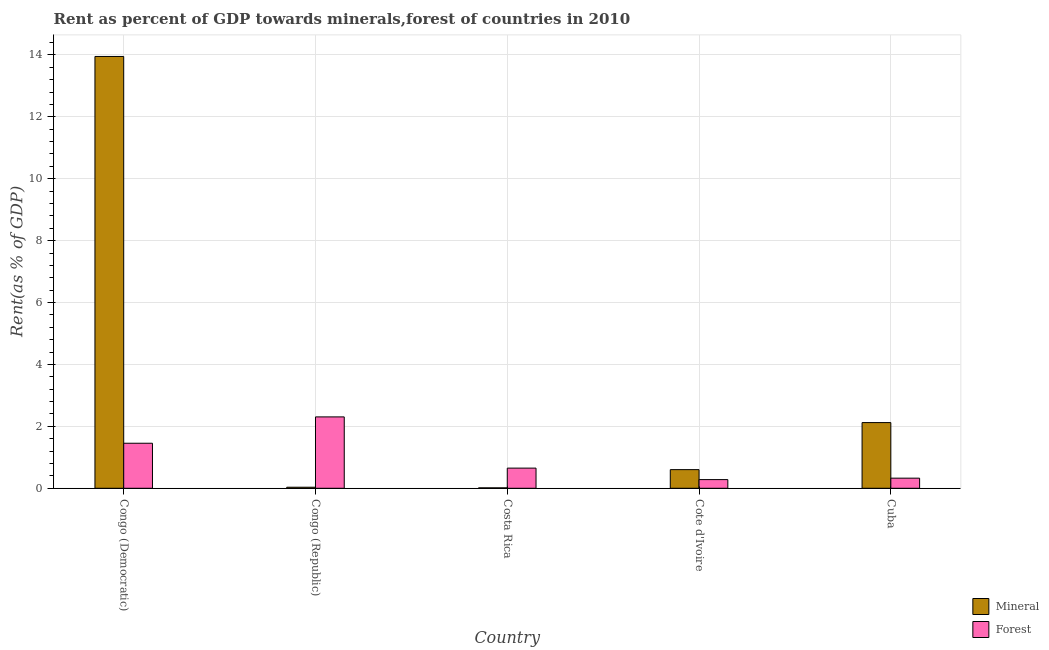How many different coloured bars are there?
Give a very brief answer. 2. How many groups of bars are there?
Ensure brevity in your answer.  5. Are the number of bars per tick equal to the number of legend labels?
Ensure brevity in your answer.  Yes. How many bars are there on the 2nd tick from the left?
Ensure brevity in your answer.  2. In how many cases, is the number of bars for a given country not equal to the number of legend labels?
Your answer should be compact. 0. What is the mineral rent in Cote d'Ivoire?
Offer a very short reply. 0.6. Across all countries, what is the maximum forest rent?
Make the answer very short. 2.31. Across all countries, what is the minimum forest rent?
Keep it short and to the point. 0.28. In which country was the forest rent maximum?
Offer a terse response. Congo (Republic). In which country was the forest rent minimum?
Keep it short and to the point. Cote d'Ivoire. What is the total forest rent in the graph?
Make the answer very short. 5.02. What is the difference between the mineral rent in Cote d'Ivoire and that in Cuba?
Make the answer very short. -1.52. What is the difference between the forest rent in Cuba and the mineral rent in Costa Rica?
Your response must be concise. 0.31. What is the average mineral rent per country?
Make the answer very short. 3.34. What is the difference between the mineral rent and forest rent in Congo (Republic)?
Your answer should be compact. -2.27. In how many countries, is the forest rent greater than 4 %?
Offer a very short reply. 0. What is the ratio of the mineral rent in Costa Rica to that in Cote d'Ivoire?
Keep it short and to the point. 0.02. What is the difference between the highest and the second highest mineral rent?
Keep it short and to the point. 11.83. What is the difference between the highest and the lowest mineral rent?
Your answer should be very brief. 13.93. Is the sum of the mineral rent in Congo (Republic) and Cuba greater than the maximum forest rent across all countries?
Provide a succinct answer. No. What does the 2nd bar from the left in Costa Rica represents?
Give a very brief answer. Forest. What does the 1st bar from the right in Cote d'Ivoire represents?
Provide a short and direct response. Forest. How many bars are there?
Give a very brief answer. 10. Are all the bars in the graph horizontal?
Provide a succinct answer. No. How many countries are there in the graph?
Offer a very short reply. 5. Does the graph contain grids?
Provide a short and direct response. Yes. Where does the legend appear in the graph?
Keep it short and to the point. Bottom right. How are the legend labels stacked?
Your response must be concise. Vertical. What is the title of the graph?
Make the answer very short. Rent as percent of GDP towards minerals,forest of countries in 2010. What is the label or title of the Y-axis?
Your answer should be very brief. Rent(as % of GDP). What is the Rent(as % of GDP) in Mineral in Congo (Democratic)?
Your answer should be compact. 13.95. What is the Rent(as % of GDP) in Forest in Congo (Democratic)?
Give a very brief answer. 1.45. What is the Rent(as % of GDP) in Mineral in Congo (Republic)?
Your answer should be compact. 0.03. What is the Rent(as % of GDP) of Forest in Congo (Republic)?
Provide a short and direct response. 2.31. What is the Rent(as % of GDP) of Mineral in Costa Rica?
Your response must be concise. 0.01. What is the Rent(as % of GDP) of Forest in Costa Rica?
Ensure brevity in your answer.  0.65. What is the Rent(as % of GDP) in Mineral in Cote d'Ivoire?
Provide a short and direct response. 0.6. What is the Rent(as % of GDP) of Forest in Cote d'Ivoire?
Make the answer very short. 0.28. What is the Rent(as % of GDP) in Mineral in Cuba?
Keep it short and to the point. 2.12. What is the Rent(as % of GDP) in Forest in Cuba?
Your answer should be very brief. 0.33. Across all countries, what is the maximum Rent(as % of GDP) of Mineral?
Make the answer very short. 13.95. Across all countries, what is the maximum Rent(as % of GDP) of Forest?
Keep it short and to the point. 2.31. Across all countries, what is the minimum Rent(as % of GDP) of Mineral?
Your response must be concise. 0.01. Across all countries, what is the minimum Rent(as % of GDP) of Forest?
Make the answer very short. 0.28. What is the total Rent(as % of GDP) in Mineral in the graph?
Your answer should be compact. 16.72. What is the total Rent(as % of GDP) of Forest in the graph?
Make the answer very short. 5.02. What is the difference between the Rent(as % of GDP) of Mineral in Congo (Democratic) and that in Congo (Republic)?
Keep it short and to the point. 13.91. What is the difference between the Rent(as % of GDP) in Forest in Congo (Democratic) and that in Congo (Republic)?
Offer a terse response. -0.85. What is the difference between the Rent(as % of GDP) in Mineral in Congo (Democratic) and that in Costa Rica?
Offer a terse response. 13.93. What is the difference between the Rent(as % of GDP) of Forest in Congo (Democratic) and that in Costa Rica?
Provide a short and direct response. 0.8. What is the difference between the Rent(as % of GDP) of Mineral in Congo (Democratic) and that in Cote d'Ivoire?
Provide a succinct answer. 13.35. What is the difference between the Rent(as % of GDP) in Forest in Congo (Democratic) and that in Cote d'Ivoire?
Your response must be concise. 1.17. What is the difference between the Rent(as % of GDP) of Mineral in Congo (Democratic) and that in Cuba?
Your answer should be compact. 11.83. What is the difference between the Rent(as % of GDP) in Forest in Congo (Democratic) and that in Cuba?
Give a very brief answer. 1.13. What is the difference between the Rent(as % of GDP) of Mineral in Congo (Republic) and that in Costa Rica?
Ensure brevity in your answer.  0.02. What is the difference between the Rent(as % of GDP) of Forest in Congo (Republic) and that in Costa Rica?
Make the answer very short. 1.65. What is the difference between the Rent(as % of GDP) of Mineral in Congo (Republic) and that in Cote d'Ivoire?
Your response must be concise. -0.57. What is the difference between the Rent(as % of GDP) in Forest in Congo (Republic) and that in Cote d'Ivoire?
Give a very brief answer. 2.03. What is the difference between the Rent(as % of GDP) in Mineral in Congo (Republic) and that in Cuba?
Provide a short and direct response. -2.09. What is the difference between the Rent(as % of GDP) of Forest in Congo (Republic) and that in Cuba?
Make the answer very short. 1.98. What is the difference between the Rent(as % of GDP) of Mineral in Costa Rica and that in Cote d'Ivoire?
Provide a succinct answer. -0.59. What is the difference between the Rent(as % of GDP) of Forest in Costa Rica and that in Cote d'Ivoire?
Ensure brevity in your answer.  0.37. What is the difference between the Rent(as % of GDP) of Mineral in Costa Rica and that in Cuba?
Provide a short and direct response. -2.11. What is the difference between the Rent(as % of GDP) in Forest in Costa Rica and that in Cuba?
Ensure brevity in your answer.  0.32. What is the difference between the Rent(as % of GDP) of Mineral in Cote d'Ivoire and that in Cuba?
Your answer should be compact. -1.52. What is the difference between the Rent(as % of GDP) in Forest in Cote d'Ivoire and that in Cuba?
Your answer should be very brief. -0.05. What is the difference between the Rent(as % of GDP) in Mineral in Congo (Democratic) and the Rent(as % of GDP) in Forest in Congo (Republic)?
Give a very brief answer. 11.64. What is the difference between the Rent(as % of GDP) in Mineral in Congo (Democratic) and the Rent(as % of GDP) in Forest in Costa Rica?
Provide a succinct answer. 13.3. What is the difference between the Rent(as % of GDP) in Mineral in Congo (Democratic) and the Rent(as % of GDP) in Forest in Cote d'Ivoire?
Provide a succinct answer. 13.67. What is the difference between the Rent(as % of GDP) of Mineral in Congo (Democratic) and the Rent(as % of GDP) of Forest in Cuba?
Your answer should be very brief. 13.62. What is the difference between the Rent(as % of GDP) of Mineral in Congo (Republic) and the Rent(as % of GDP) of Forest in Costa Rica?
Your response must be concise. -0.62. What is the difference between the Rent(as % of GDP) of Mineral in Congo (Republic) and the Rent(as % of GDP) of Forest in Cote d'Ivoire?
Give a very brief answer. -0.25. What is the difference between the Rent(as % of GDP) in Mineral in Congo (Republic) and the Rent(as % of GDP) in Forest in Cuba?
Provide a short and direct response. -0.29. What is the difference between the Rent(as % of GDP) of Mineral in Costa Rica and the Rent(as % of GDP) of Forest in Cote d'Ivoire?
Your answer should be very brief. -0.27. What is the difference between the Rent(as % of GDP) of Mineral in Costa Rica and the Rent(as % of GDP) of Forest in Cuba?
Your answer should be compact. -0.31. What is the difference between the Rent(as % of GDP) in Mineral in Cote d'Ivoire and the Rent(as % of GDP) in Forest in Cuba?
Keep it short and to the point. 0.28. What is the average Rent(as % of GDP) of Mineral per country?
Offer a terse response. 3.34. What is the difference between the Rent(as % of GDP) of Mineral and Rent(as % of GDP) of Forest in Congo (Democratic)?
Offer a very short reply. 12.49. What is the difference between the Rent(as % of GDP) in Mineral and Rent(as % of GDP) in Forest in Congo (Republic)?
Ensure brevity in your answer.  -2.27. What is the difference between the Rent(as % of GDP) of Mineral and Rent(as % of GDP) of Forest in Costa Rica?
Your answer should be very brief. -0.64. What is the difference between the Rent(as % of GDP) in Mineral and Rent(as % of GDP) in Forest in Cote d'Ivoire?
Provide a succinct answer. 0.32. What is the difference between the Rent(as % of GDP) of Mineral and Rent(as % of GDP) of Forest in Cuba?
Provide a short and direct response. 1.8. What is the ratio of the Rent(as % of GDP) in Mineral in Congo (Democratic) to that in Congo (Republic)?
Make the answer very short. 411.64. What is the ratio of the Rent(as % of GDP) of Forest in Congo (Democratic) to that in Congo (Republic)?
Your response must be concise. 0.63. What is the ratio of the Rent(as % of GDP) of Mineral in Congo (Democratic) to that in Costa Rica?
Your response must be concise. 1009.42. What is the ratio of the Rent(as % of GDP) of Forest in Congo (Democratic) to that in Costa Rica?
Provide a succinct answer. 2.23. What is the ratio of the Rent(as % of GDP) in Mineral in Congo (Democratic) to that in Cote d'Ivoire?
Keep it short and to the point. 23.15. What is the ratio of the Rent(as % of GDP) in Forest in Congo (Democratic) to that in Cote d'Ivoire?
Offer a terse response. 5.19. What is the ratio of the Rent(as % of GDP) in Mineral in Congo (Democratic) to that in Cuba?
Keep it short and to the point. 6.57. What is the ratio of the Rent(as % of GDP) of Forest in Congo (Democratic) to that in Cuba?
Make the answer very short. 4.45. What is the ratio of the Rent(as % of GDP) in Mineral in Congo (Republic) to that in Costa Rica?
Your answer should be very brief. 2.45. What is the ratio of the Rent(as % of GDP) of Forest in Congo (Republic) to that in Costa Rica?
Keep it short and to the point. 3.54. What is the ratio of the Rent(as % of GDP) in Mineral in Congo (Republic) to that in Cote d'Ivoire?
Provide a short and direct response. 0.06. What is the ratio of the Rent(as % of GDP) of Forest in Congo (Republic) to that in Cote d'Ivoire?
Offer a very short reply. 8.22. What is the ratio of the Rent(as % of GDP) in Mineral in Congo (Republic) to that in Cuba?
Give a very brief answer. 0.02. What is the ratio of the Rent(as % of GDP) in Forest in Congo (Republic) to that in Cuba?
Keep it short and to the point. 7.06. What is the ratio of the Rent(as % of GDP) of Mineral in Costa Rica to that in Cote d'Ivoire?
Ensure brevity in your answer.  0.02. What is the ratio of the Rent(as % of GDP) in Forest in Costa Rica to that in Cote d'Ivoire?
Ensure brevity in your answer.  2.32. What is the ratio of the Rent(as % of GDP) of Mineral in Costa Rica to that in Cuba?
Provide a succinct answer. 0.01. What is the ratio of the Rent(as % of GDP) in Forest in Costa Rica to that in Cuba?
Give a very brief answer. 1.99. What is the ratio of the Rent(as % of GDP) in Mineral in Cote d'Ivoire to that in Cuba?
Provide a succinct answer. 0.28. What is the ratio of the Rent(as % of GDP) in Forest in Cote d'Ivoire to that in Cuba?
Give a very brief answer. 0.86. What is the difference between the highest and the second highest Rent(as % of GDP) in Mineral?
Offer a very short reply. 11.83. What is the difference between the highest and the second highest Rent(as % of GDP) in Forest?
Ensure brevity in your answer.  0.85. What is the difference between the highest and the lowest Rent(as % of GDP) in Mineral?
Provide a short and direct response. 13.93. What is the difference between the highest and the lowest Rent(as % of GDP) of Forest?
Offer a very short reply. 2.03. 